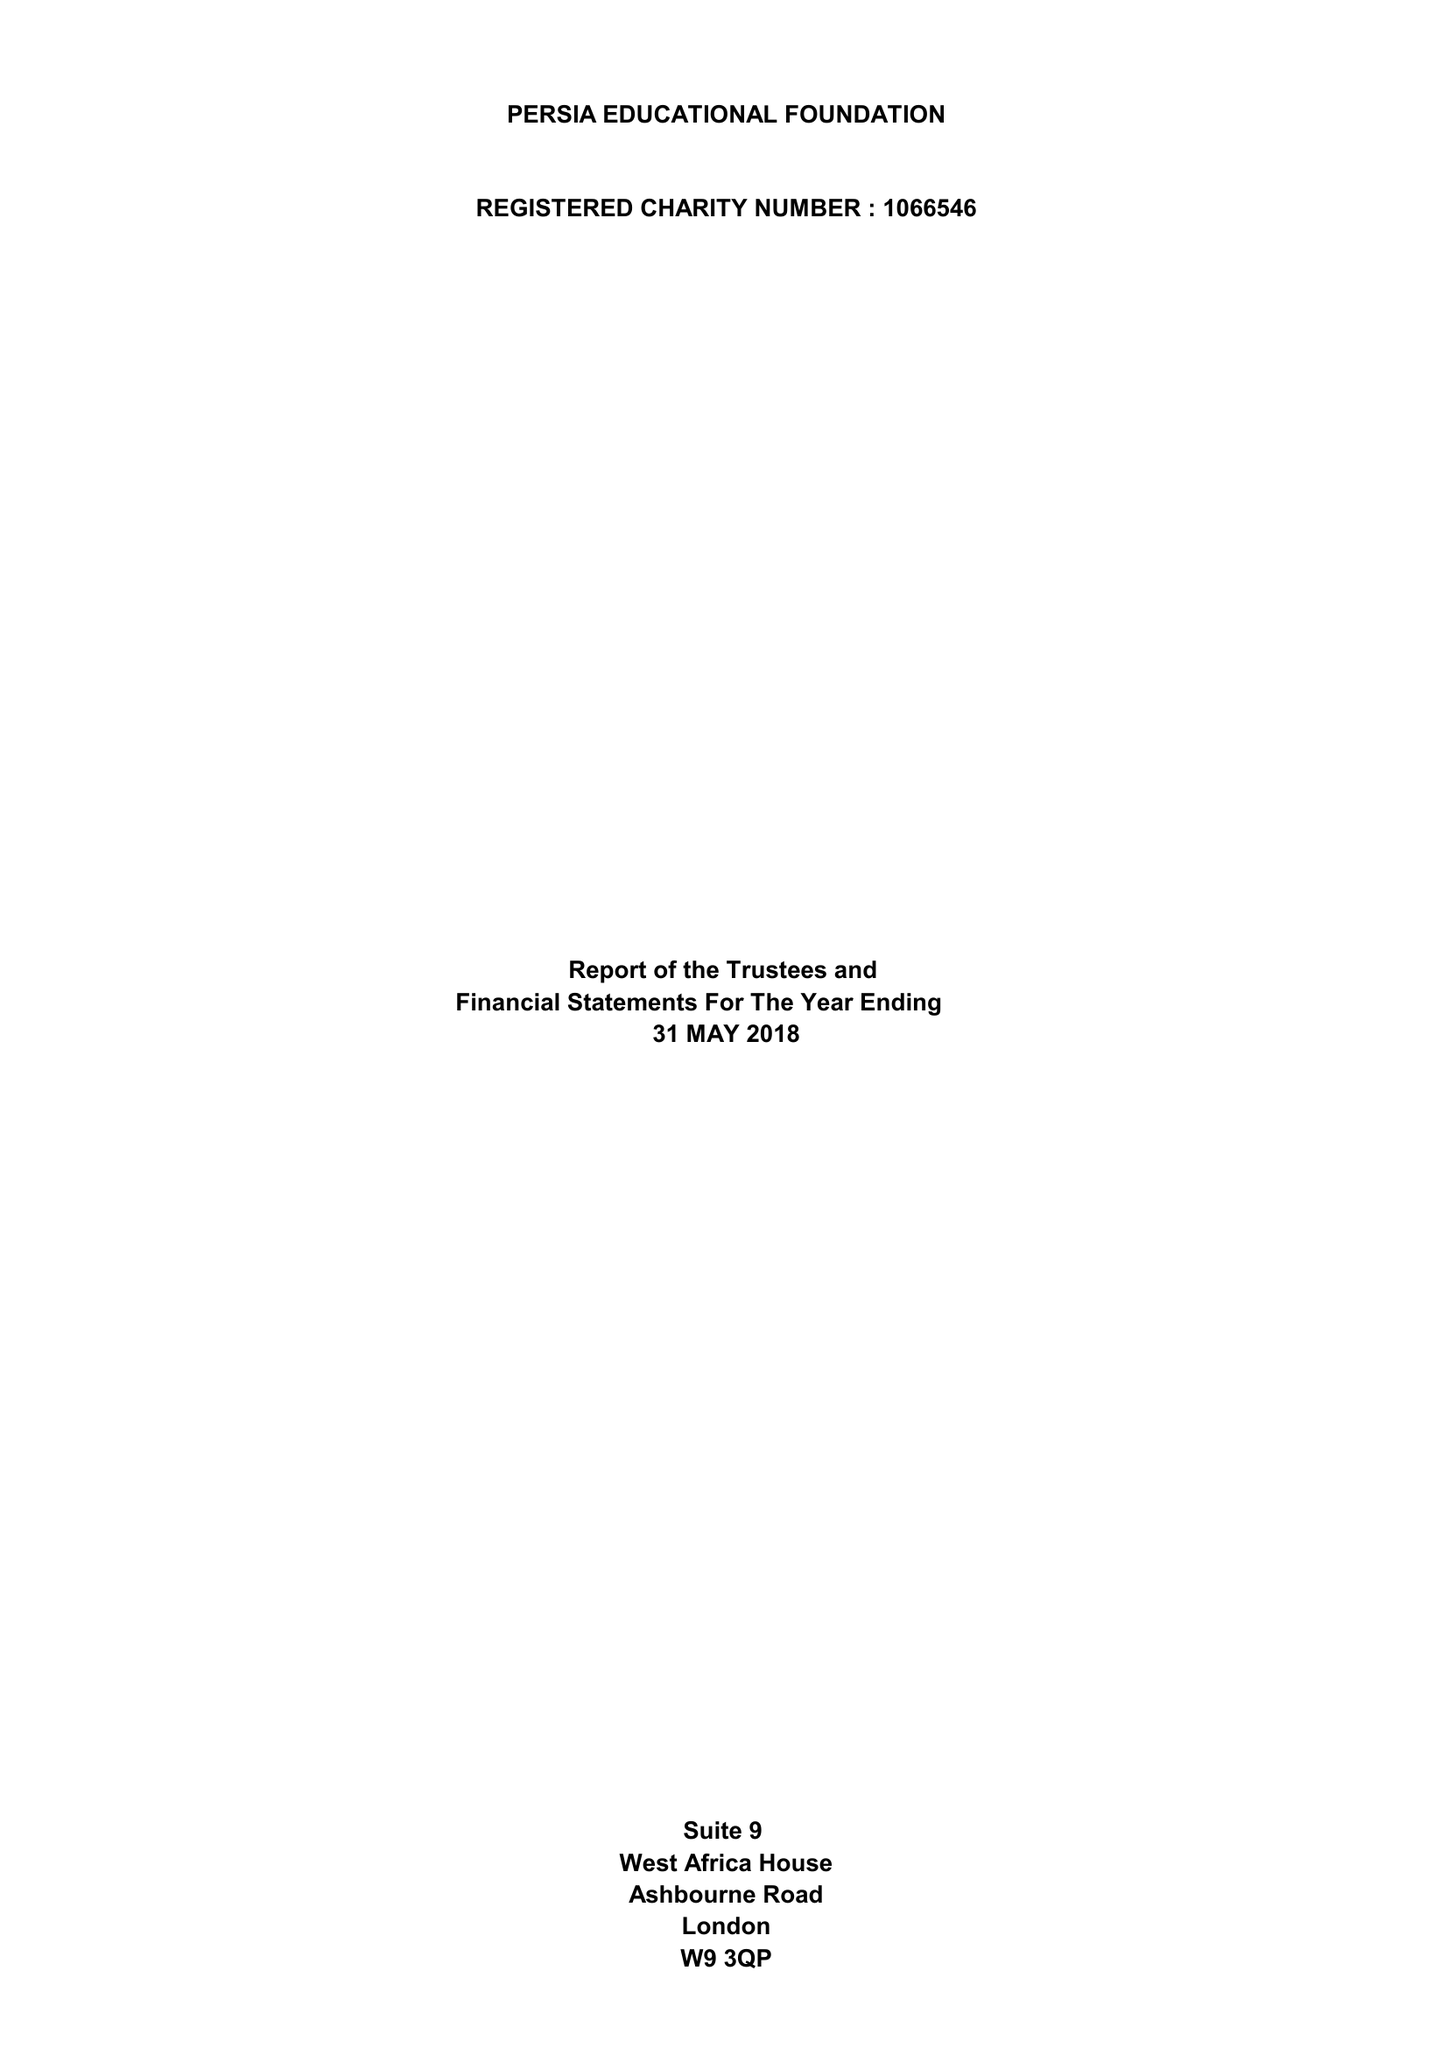What is the value for the charity_name?
Answer the question using a single word or phrase. Persia Educational Foundation 